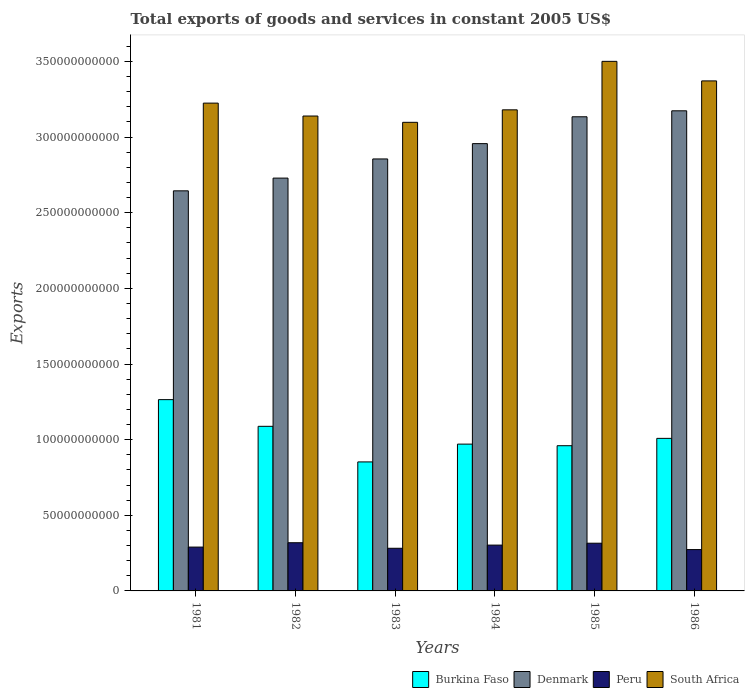How many groups of bars are there?
Keep it short and to the point. 6. How many bars are there on the 6th tick from the right?
Offer a very short reply. 4. What is the label of the 2nd group of bars from the left?
Make the answer very short. 1982. What is the total exports of goods and services in Peru in 1981?
Keep it short and to the point. 2.90e+1. Across all years, what is the maximum total exports of goods and services in Peru?
Provide a succinct answer. 3.19e+1. Across all years, what is the minimum total exports of goods and services in South Africa?
Your answer should be compact. 3.10e+11. In which year was the total exports of goods and services in Denmark maximum?
Ensure brevity in your answer.  1986. What is the total total exports of goods and services in Peru in the graph?
Your response must be concise. 1.78e+11. What is the difference between the total exports of goods and services in Peru in 1981 and that in 1984?
Keep it short and to the point. -1.32e+09. What is the difference between the total exports of goods and services in Denmark in 1981 and the total exports of goods and services in Burkina Faso in 1982?
Your response must be concise. 1.56e+11. What is the average total exports of goods and services in Denmark per year?
Give a very brief answer. 2.92e+11. In the year 1981, what is the difference between the total exports of goods and services in Denmark and total exports of goods and services in Peru?
Give a very brief answer. 2.36e+11. What is the ratio of the total exports of goods and services in Peru in 1982 to that in 1984?
Give a very brief answer. 1.05. Is the total exports of goods and services in Denmark in 1985 less than that in 1986?
Ensure brevity in your answer.  Yes. What is the difference between the highest and the second highest total exports of goods and services in Denmark?
Keep it short and to the point. 3.95e+09. What is the difference between the highest and the lowest total exports of goods and services in Denmark?
Your response must be concise. 5.29e+1. In how many years, is the total exports of goods and services in Burkina Faso greater than the average total exports of goods and services in Burkina Faso taken over all years?
Offer a terse response. 2. What does the 2nd bar from the left in 1986 represents?
Your response must be concise. Denmark. Is it the case that in every year, the sum of the total exports of goods and services in Burkina Faso and total exports of goods and services in Denmark is greater than the total exports of goods and services in Peru?
Offer a terse response. Yes. Are the values on the major ticks of Y-axis written in scientific E-notation?
Make the answer very short. No. Where does the legend appear in the graph?
Offer a very short reply. Bottom right. What is the title of the graph?
Keep it short and to the point. Total exports of goods and services in constant 2005 US$. What is the label or title of the Y-axis?
Your answer should be compact. Exports. What is the Exports in Burkina Faso in 1981?
Offer a terse response. 1.26e+11. What is the Exports in Denmark in 1981?
Your answer should be very brief. 2.64e+11. What is the Exports of Peru in 1981?
Your answer should be very brief. 2.90e+1. What is the Exports in South Africa in 1981?
Give a very brief answer. 3.22e+11. What is the Exports of Burkina Faso in 1982?
Your answer should be compact. 1.09e+11. What is the Exports in Denmark in 1982?
Your answer should be compact. 2.73e+11. What is the Exports of Peru in 1982?
Offer a terse response. 3.19e+1. What is the Exports in South Africa in 1982?
Your response must be concise. 3.14e+11. What is the Exports of Burkina Faso in 1983?
Offer a very short reply. 8.53e+1. What is the Exports of Denmark in 1983?
Give a very brief answer. 2.86e+11. What is the Exports of Peru in 1983?
Offer a very short reply. 2.82e+1. What is the Exports in South Africa in 1983?
Ensure brevity in your answer.  3.10e+11. What is the Exports in Burkina Faso in 1984?
Make the answer very short. 9.70e+1. What is the Exports of Denmark in 1984?
Provide a succinct answer. 2.96e+11. What is the Exports in Peru in 1984?
Provide a succinct answer. 3.03e+1. What is the Exports in South Africa in 1984?
Offer a very short reply. 3.18e+11. What is the Exports of Burkina Faso in 1985?
Your answer should be compact. 9.60e+1. What is the Exports of Denmark in 1985?
Keep it short and to the point. 3.13e+11. What is the Exports in Peru in 1985?
Give a very brief answer. 3.15e+1. What is the Exports in South Africa in 1985?
Make the answer very short. 3.50e+11. What is the Exports of Burkina Faso in 1986?
Your response must be concise. 1.01e+11. What is the Exports of Denmark in 1986?
Keep it short and to the point. 3.17e+11. What is the Exports of Peru in 1986?
Give a very brief answer. 2.73e+1. What is the Exports of South Africa in 1986?
Provide a succinct answer. 3.37e+11. Across all years, what is the maximum Exports in Burkina Faso?
Offer a terse response. 1.26e+11. Across all years, what is the maximum Exports of Denmark?
Give a very brief answer. 3.17e+11. Across all years, what is the maximum Exports of Peru?
Provide a succinct answer. 3.19e+1. Across all years, what is the maximum Exports of South Africa?
Ensure brevity in your answer.  3.50e+11. Across all years, what is the minimum Exports in Burkina Faso?
Make the answer very short. 8.53e+1. Across all years, what is the minimum Exports in Denmark?
Give a very brief answer. 2.64e+11. Across all years, what is the minimum Exports of Peru?
Your response must be concise. 2.73e+1. Across all years, what is the minimum Exports of South Africa?
Your answer should be compact. 3.10e+11. What is the total Exports of Burkina Faso in the graph?
Your response must be concise. 6.14e+11. What is the total Exports in Denmark in the graph?
Make the answer very short. 1.75e+12. What is the total Exports in Peru in the graph?
Provide a short and direct response. 1.78e+11. What is the total Exports in South Africa in the graph?
Offer a terse response. 1.95e+12. What is the difference between the Exports in Burkina Faso in 1981 and that in 1982?
Your answer should be very brief. 1.76e+1. What is the difference between the Exports in Denmark in 1981 and that in 1982?
Provide a succinct answer. -8.42e+09. What is the difference between the Exports of Peru in 1981 and that in 1982?
Your answer should be compact. -2.88e+09. What is the difference between the Exports of South Africa in 1981 and that in 1982?
Your response must be concise. 8.53e+09. What is the difference between the Exports in Burkina Faso in 1981 and that in 1983?
Ensure brevity in your answer.  4.12e+1. What is the difference between the Exports of Denmark in 1981 and that in 1983?
Provide a succinct answer. -2.11e+1. What is the difference between the Exports in Peru in 1981 and that in 1983?
Provide a succinct answer. 7.75e+08. What is the difference between the Exports of South Africa in 1981 and that in 1983?
Give a very brief answer. 1.27e+1. What is the difference between the Exports of Burkina Faso in 1981 and that in 1984?
Make the answer very short. 2.94e+1. What is the difference between the Exports in Denmark in 1981 and that in 1984?
Your answer should be compact. -3.12e+1. What is the difference between the Exports of Peru in 1981 and that in 1984?
Provide a succinct answer. -1.32e+09. What is the difference between the Exports of South Africa in 1981 and that in 1984?
Make the answer very short. 4.44e+09. What is the difference between the Exports in Burkina Faso in 1981 and that in 1985?
Provide a succinct answer. 3.05e+1. What is the difference between the Exports in Denmark in 1981 and that in 1985?
Offer a terse response. -4.90e+1. What is the difference between the Exports of Peru in 1981 and that in 1985?
Keep it short and to the point. -2.56e+09. What is the difference between the Exports in South Africa in 1981 and that in 1985?
Provide a succinct answer. -2.76e+1. What is the difference between the Exports in Burkina Faso in 1981 and that in 1986?
Ensure brevity in your answer.  2.56e+1. What is the difference between the Exports in Denmark in 1981 and that in 1986?
Your answer should be very brief. -5.29e+1. What is the difference between the Exports in Peru in 1981 and that in 1986?
Give a very brief answer. 1.64e+09. What is the difference between the Exports in South Africa in 1981 and that in 1986?
Ensure brevity in your answer.  -1.47e+1. What is the difference between the Exports of Burkina Faso in 1982 and that in 1983?
Your answer should be compact. 2.35e+1. What is the difference between the Exports of Denmark in 1982 and that in 1983?
Offer a terse response. -1.27e+1. What is the difference between the Exports of Peru in 1982 and that in 1983?
Offer a terse response. 3.66e+09. What is the difference between the Exports of South Africa in 1982 and that in 1983?
Keep it short and to the point. 4.17e+09. What is the difference between the Exports of Burkina Faso in 1982 and that in 1984?
Offer a terse response. 1.18e+1. What is the difference between the Exports in Denmark in 1982 and that in 1984?
Give a very brief answer. -2.28e+1. What is the difference between the Exports in Peru in 1982 and that in 1984?
Your answer should be very brief. 1.57e+09. What is the difference between the Exports in South Africa in 1982 and that in 1984?
Give a very brief answer. -4.09e+09. What is the difference between the Exports in Burkina Faso in 1982 and that in 1985?
Your answer should be compact. 1.28e+1. What is the difference between the Exports of Denmark in 1982 and that in 1985?
Provide a short and direct response. -4.05e+1. What is the difference between the Exports of Peru in 1982 and that in 1985?
Provide a succinct answer. 3.22e+08. What is the difference between the Exports of South Africa in 1982 and that in 1985?
Offer a terse response. -3.61e+1. What is the difference between the Exports in Burkina Faso in 1982 and that in 1986?
Make the answer very short. 7.96e+09. What is the difference between the Exports of Denmark in 1982 and that in 1986?
Keep it short and to the point. -4.45e+1. What is the difference between the Exports in Peru in 1982 and that in 1986?
Your answer should be very brief. 4.53e+09. What is the difference between the Exports of South Africa in 1982 and that in 1986?
Offer a very short reply. -2.32e+1. What is the difference between the Exports in Burkina Faso in 1983 and that in 1984?
Provide a succinct answer. -1.18e+1. What is the difference between the Exports of Denmark in 1983 and that in 1984?
Offer a terse response. -1.01e+1. What is the difference between the Exports of Peru in 1983 and that in 1984?
Make the answer very short. -2.09e+09. What is the difference between the Exports in South Africa in 1983 and that in 1984?
Offer a terse response. -8.26e+09. What is the difference between the Exports of Burkina Faso in 1983 and that in 1985?
Offer a very short reply. -1.07e+1. What is the difference between the Exports in Denmark in 1983 and that in 1985?
Your answer should be very brief. -2.79e+1. What is the difference between the Exports of Peru in 1983 and that in 1985?
Keep it short and to the point. -3.34e+09. What is the difference between the Exports of South Africa in 1983 and that in 1985?
Make the answer very short. -4.03e+1. What is the difference between the Exports in Burkina Faso in 1983 and that in 1986?
Keep it short and to the point. -1.56e+1. What is the difference between the Exports in Denmark in 1983 and that in 1986?
Offer a very short reply. -3.18e+1. What is the difference between the Exports of Peru in 1983 and that in 1986?
Your response must be concise. 8.69e+08. What is the difference between the Exports of South Africa in 1983 and that in 1986?
Your answer should be compact. -2.74e+1. What is the difference between the Exports of Burkina Faso in 1984 and that in 1985?
Ensure brevity in your answer.  1.05e+09. What is the difference between the Exports in Denmark in 1984 and that in 1985?
Give a very brief answer. -1.78e+1. What is the difference between the Exports in Peru in 1984 and that in 1985?
Keep it short and to the point. -1.25e+09. What is the difference between the Exports in South Africa in 1984 and that in 1985?
Keep it short and to the point. -3.20e+1. What is the difference between the Exports of Burkina Faso in 1984 and that in 1986?
Offer a very short reply. -3.80e+09. What is the difference between the Exports in Denmark in 1984 and that in 1986?
Keep it short and to the point. -2.17e+1. What is the difference between the Exports of Peru in 1984 and that in 1986?
Make the answer very short. 2.96e+09. What is the difference between the Exports in South Africa in 1984 and that in 1986?
Your response must be concise. -1.91e+1. What is the difference between the Exports in Burkina Faso in 1985 and that in 1986?
Ensure brevity in your answer.  -4.85e+09. What is the difference between the Exports of Denmark in 1985 and that in 1986?
Provide a succinct answer. -3.95e+09. What is the difference between the Exports in Peru in 1985 and that in 1986?
Give a very brief answer. 4.21e+09. What is the difference between the Exports in South Africa in 1985 and that in 1986?
Offer a very short reply. 1.29e+1. What is the difference between the Exports in Burkina Faso in 1981 and the Exports in Denmark in 1982?
Provide a short and direct response. -1.46e+11. What is the difference between the Exports in Burkina Faso in 1981 and the Exports in Peru in 1982?
Make the answer very short. 9.46e+1. What is the difference between the Exports in Burkina Faso in 1981 and the Exports in South Africa in 1982?
Your answer should be very brief. -1.87e+11. What is the difference between the Exports in Denmark in 1981 and the Exports in Peru in 1982?
Give a very brief answer. 2.33e+11. What is the difference between the Exports in Denmark in 1981 and the Exports in South Africa in 1982?
Make the answer very short. -4.95e+1. What is the difference between the Exports of Peru in 1981 and the Exports of South Africa in 1982?
Provide a succinct answer. -2.85e+11. What is the difference between the Exports in Burkina Faso in 1981 and the Exports in Denmark in 1983?
Make the answer very short. -1.59e+11. What is the difference between the Exports of Burkina Faso in 1981 and the Exports of Peru in 1983?
Give a very brief answer. 9.83e+1. What is the difference between the Exports of Burkina Faso in 1981 and the Exports of South Africa in 1983?
Your answer should be compact. -1.83e+11. What is the difference between the Exports in Denmark in 1981 and the Exports in Peru in 1983?
Offer a very short reply. 2.36e+11. What is the difference between the Exports of Denmark in 1981 and the Exports of South Africa in 1983?
Provide a succinct answer. -4.53e+1. What is the difference between the Exports of Peru in 1981 and the Exports of South Africa in 1983?
Give a very brief answer. -2.81e+11. What is the difference between the Exports of Burkina Faso in 1981 and the Exports of Denmark in 1984?
Give a very brief answer. -1.69e+11. What is the difference between the Exports in Burkina Faso in 1981 and the Exports in Peru in 1984?
Keep it short and to the point. 9.62e+1. What is the difference between the Exports in Burkina Faso in 1981 and the Exports in South Africa in 1984?
Provide a short and direct response. -1.92e+11. What is the difference between the Exports of Denmark in 1981 and the Exports of Peru in 1984?
Make the answer very short. 2.34e+11. What is the difference between the Exports of Denmark in 1981 and the Exports of South Africa in 1984?
Provide a succinct answer. -5.35e+1. What is the difference between the Exports in Peru in 1981 and the Exports in South Africa in 1984?
Your response must be concise. -2.89e+11. What is the difference between the Exports of Burkina Faso in 1981 and the Exports of Denmark in 1985?
Provide a succinct answer. -1.87e+11. What is the difference between the Exports in Burkina Faso in 1981 and the Exports in Peru in 1985?
Offer a terse response. 9.49e+1. What is the difference between the Exports of Burkina Faso in 1981 and the Exports of South Africa in 1985?
Your answer should be very brief. -2.24e+11. What is the difference between the Exports of Denmark in 1981 and the Exports of Peru in 1985?
Offer a terse response. 2.33e+11. What is the difference between the Exports of Denmark in 1981 and the Exports of South Africa in 1985?
Make the answer very short. -8.56e+1. What is the difference between the Exports in Peru in 1981 and the Exports in South Africa in 1985?
Your answer should be compact. -3.21e+11. What is the difference between the Exports of Burkina Faso in 1981 and the Exports of Denmark in 1986?
Your answer should be compact. -1.91e+11. What is the difference between the Exports in Burkina Faso in 1981 and the Exports in Peru in 1986?
Make the answer very short. 9.91e+1. What is the difference between the Exports in Burkina Faso in 1981 and the Exports in South Africa in 1986?
Keep it short and to the point. -2.11e+11. What is the difference between the Exports in Denmark in 1981 and the Exports in Peru in 1986?
Your answer should be very brief. 2.37e+11. What is the difference between the Exports in Denmark in 1981 and the Exports in South Africa in 1986?
Your answer should be very brief. -7.27e+1. What is the difference between the Exports of Peru in 1981 and the Exports of South Africa in 1986?
Your answer should be very brief. -3.08e+11. What is the difference between the Exports of Burkina Faso in 1982 and the Exports of Denmark in 1983?
Provide a succinct answer. -1.77e+11. What is the difference between the Exports of Burkina Faso in 1982 and the Exports of Peru in 1983?
Ensure brevity in your answer.  8.06e+1. What is the difference between the Exports of Burkina Faso in 1982 and the Exports of South Africa in 1983?
Give a very brief answer. -2.01e+11. What is the difference between the Exports in Denmark in 1982 and the Exports in Peru in 1983?
Keep it short and to the point. 2.45e+11. What is the difference between the Exports of Denmark in 1982 and the Exports of South Africa in 1983?
Give a very brief answer. -3.69e+1. What is the difference between the Exports of Peru in 1982 and the Exports of South Africa in 1983?
Offer a terse response. -2.78e+11. What is the difference between the Exports of Burkina Faso in 1982 and the Exports of Denmark in 1984?
Offer a very short reply. -1.87e+11. What is the difference between the Exports in Burkina Faso in 1982 and the Exports in Peru in 1984?
Offer a terse response. 7.85e+1. What is the difference between the Exports in Burkina Faso in 1982 and the Exports in South Africa in 1984?
Give a very brief answer. -2.09e+11. What is the difference between the Exports in Denmark in 1982 and the Exports in Peru in 1984?
Make the answer very short. 2.43e+11. What is the difference between the Exports of Denmark in 1982 and the Exports of South Africa in 1984?
Provide a short and direct response. -4.51e+1. What is the difference between the Exports in Peru in 1982 and the Exports in South Africa in 1984?
Provide a succinct answer. -2.86e+11. What is the difference between the Exports of Burkina Faso in 1982 and the Exports of Denmark in 1985?
Your response must be concise. -2.05e+11. What is the difference between the Exports in Burkina Faso in 1982 and the Exports in Peru in 1985?
Your answer should be very brief. 7.73e+1. What is the difference between the Exports in Burkina Faso in 1982 and the Exports in South Africa in 1985?
Offer a very short reply. -2.41e+11. What is the difference between the Exports of Denmark in 1982 and the Exports of Peru in 1985?
Give a very brief answer. 2.41e+11. What is the difference between the Exports in Denmark in 1982 and the Exports in South Africa in 1985?
Provide a succinct answer. -7.72e+1. What is the difference between the Exports of Peru in 1982 and the Exports of South Africa in 1985?
Offer a terse response. -3.18e+11. What is the difference between the Exports of Burkina Faso in 1982 and the Exports of Denmark in 1986?
Your response must be concise. -2.09e+11. What is the difference between the Exports in Burkina Faso in 1982 and the Exports in Peru in 1986?
Provide a succinct answer. 8.15e+1. What is the difference between the Exports of Burkina Faso in 1982 and the Exports of South Africa in 1986?
Your response must be concise. -2.28e+11. What is the difference between the Exports of Denmark in 1982 and the Exports of Peru in 1986?
Ensure brevity in your answer.  2.46e+11. What is the difference between the Exports of Denmark in 1982 and the Exports of South Africa in 1986?
Give a very brief answer. -6.43e+1. What is the difference between the Exports of Peru in 1982 and the Exports of South Africa in 1986?
Provide a succinct answer. -3.05e+11. What is the difference between the Exports in Burkina Faso in 1983 and the Exports in Denmark in 1984?
Your response must be concise. -2.10e+11. What is the difference between the Exports of Burkina Faso in 1983 and the Exports of Peru in 1984?
Offer a very short reply. 5.50e+1. What is the difference between the Exports in Burkina Faso in 1983 and the Exports in South Africa in 1984?
Provide a short and direct response. -2.33e+11. What is the difference between the Exports of Denmark in 1983 and the Exports of Peru in 1984?
Ensure brevity in your answer.  2.55e+11. What is the difference between the Exports in Denmark in 1983 and the Exports in South Africa in 1984?
Offer a very short reply. -3.25e+1. What is the difference between the Exports in Peru in 1983 and the Exports in South Africa in 1984?
Offer a very short reply. -2.90e+11. What is the difference between the Exports of Burkina Faso in 1983 and the Exports of Denmark in 1985?
Your response must be concise. -2.28e+11. What is the difference between the Exports of Burkina Faso in 1983 and the Exports of Peru in 1985?
Ensure brevity in your answer.  5.37e+1. What is the difference between the Exports in Burkina Faso in 1983 and the Exports in South Africa in 1985?
Provide a short and direct response. -2.65e+11. What is the difference between the Exports in Denmark in 1983 and the Exports in Peru in 1985?
Your response must be concise. 2.54e+11. What is the difference between the Exports in Denmark in 1983 and the Exports in South Africa in 1985?
Give a very brief answer. -6.45e+1. What is the difference between the Exports of Peru in 1983 and the Exports of South Africa in 1985?
Give a very brief answer. -3.22e+11. What is the difference between the Exports in Burkina Faso in 1983 and the Exports in Denmark in 1986?
Give a very brief answer. -2.32e+11. What is the difference between the Exports in Burkina Faso in 1983 and the Exports in Peru in 1986?
Provide a short and direct response. 5.80e+1. What is the difference between the Exports of Burkina Faso in 1983 and the Exports of South Africa in 1986?
Your response must be concise. -2.52e+11. What is the difference between the Exports of Denmark in 1983 and the Exports of Peru in 1986?
Provide a succinct answer. 2.58e+11. What is the difference between the Exports in Denmark in 1983 and the Exports in South Africa in 1986?
Give a very brief answer. -5.16e+1. What is the difference between the Exports of Peru in 1983 and the Exports of South Africa in 1986?
Ensure brevity in your answer.  -3.09e+11. What is the difference between the Exports in Burkina Faso in 1984 and the Exports in Denmark in 1985?
Provide a succinct answer. -2.16e+11. What is the difference between the Exports in Burkina Faso in 1984 and the Exports in Peru in 1985?
Provide a short and direct response. 6.55e+1. What is the difference between the Exports in Burkina Faso in 1984 and the Exports in South Africa in 1985?
Give a very brief answer. -2.53e+11. What is the difference between the Exports of Denmark in 1984 and the Exports of Peru in 1985?
Offer a terse response. 2.64e+11. What is the difference between the Exports in Denmark in 1984 and the Exports in South Africa in 1985?
Ensure brevity in your answer.  -5.44e+1. What is the difference between the Exports of Peru in 1984 and the Exports of South Africa in 1985?
Ensure brevity in your answer.  -3.20e+11. What is the difference between the Exports of Burkina Faso in 1984 and the Exports of Denmark in 1986?
Provide a short and direct response. -2.20e+11. What is the difference between the Exports in Burkina Faso in 1984 and the Exports in Peru in 1986?
Your response must be concise. 6.97e+1. What is the difference between the Exports of Burkina Faso in 1984 and the Exports of South Africa in 1986?
Your response must be concise. -2.40e+11. What is the difference between the Exports of Denmark in 1984 and the Exports of Peru in 1986?
Your answer should be compact. 2.68e+11. What is the difference between the Exports of Denmark in 1984 and the Exports of South Africa in 1986?
Offer a terse response. -4.15e+1. What is the difference between the Exports in Peru in 1984 and the Exports in South Africa in 1986?
Ensure brevity in your answer.  -3.07e+11. What is the difference between the Exports of Burkina Faso in 1985 and the Exports of Denmark in 1986?
Provide a succinct answer. -2.21e+11. What is the difference between the Exports in Burkina Faso in 1985 and the Exports in Peru in 1986?
Offer a very short reply. 6.87e+1. What is the difference between the Exports of Burkina Faso in 1985 and the Exports of South Africa in 1986?
Give a very brief answer. -2.41e+11. What is the difference between the Exports of Denmark in 1985 and the Exports of Peru in 1986?
Keep it short and to the point. 2.86e+11. What is the difference between the Exports in Denmark in 1985 and the Exports in South Africa in 1986?
Make the answer very short. -2.37e+1. What is the difference between the Exports of Peru in 1985 and the Exports of South Africa in 1986?
Provide a succinct answer. -3.06e+11. What is the average Exports of Burkina Faso per year?
Keep it short and to the point. 1.02e+11. What is the average Exports in Denmark per year?
Give a very brief answer. 2.92e+11. What is the average Exports in Peru per year?
Your answer should be compact. 2.97e+1. What is the average Exports in South Africa per year?
Keep it short and to the point. 3.25e+11. In the year 1981, what is the difference between the Exports in Burkina Faso and Exports in Denmark?
Keep it short and to the point. -1.38e+11. In the year 1981, what is the difference between the Exports of Burkina Faso and Exports of Peru?
Provide a succinct answer. 9.75e+1. In the year 1981, what is the difference between the Exports of Burkina Faso and Exports of South Africa?
Keep it short and to the point. -1.96e+11. In the year 1981, what is the difference between the Exports in Denmark and Exports in Peru?
Keep it short and to the point. 2.36e+11. In the year 1981, what is the difference between the Exports in Denmark and Exports in South Africa?
Offer a terse response. -5.80e+1. In the year 1981, what is the difference between the Exports of Peru and Exports of South Africa?
Ensure brevity in your answer.  -2.93e+11. In the year 1982, what is the difference between the Exports of Burkina Faso and Exports of Denmark?
Your answer should be compact. -1.64e+11. In the year 1982, what is the difference between the Exports of Burkina Faso and Exports of Peru?
Your answer should be very brief. 7.70e+1. In the year 1982, what is the difference between the Exports in Burkina Faso and Exports in South Africa?
Your answer should be very brief. -2.05e+11. In the year 1982, what is the difference between the Exports of Denmark and Exports of Peru?
Provide a succinct answer. 2.41e+11. In the year 1982, what is the difference between the Exports of Denmark and Exports of South Africa?
Offer a terse response. -4.10e+1. In the year 1982, what is the difference between the Exports of Peru and Exports of South Africa?
Provide a short and direct response. -2.82e+11. In the year 1983, what is the difference between the Exports of Burkina Faso and Exports of Denmark?
Offer a terse response. -2.00e+11. In the year 1983, what is the difference between the Exports of Burkina Faso and Exports of Peru?
Ensure brevity in your answer.  5.71e+1. In the year 1983, what is the difference between the Exports in Burkina Faso and Exports in South Africa?
Ensure brevity in your answer.  -2.24e+11. In the year 1983, what is the difference between the Exports in Denmark and Exports in Peru?
Provide a succinct answer. 2.57e+11. In the year 1983, what is the difference between the Exports in Denmark and Exports in South Africa?
Give a very brief answer. -2.42e+1. In the year 1983, what is the difference between the Exports in Peru and Exports in South Africa?
Make the answer very short. -2.82e+11. In the year 1984, what is the difference between the Exports of Burkina Faso and Exports of Denmark?
Offer a very short reply. -1.99e+11. In the year 1984, what is the difference between the Exports in Burkina Faso and Exports in Peru?
Your response must be concise. 6.68e+1. In the year 1984, what is the difference between the Exports in Burkina Faso and Exports in South Africa?
Keep it short and to the point. -2.21e+11. In the year 1984, what is the difference between the Exports in Denmark and Exports in Peru?
Provide a succinct answer. 2.65e+11. In the year 1984, what is the difference between the Exports of Denmark and Exports of South Africa?
Your response must be concise. -2.23e+1. In the year 1984, what is the difference between the Exports in Peru and Exports in South Africa?
Keep it short and to the point. -2.88e+11. In the year 1985, what is the difference between the Exports in Burkina Faso and Exports in Denmark?
Make the answer very short. -2.17e+11. In the year 1985, what is the difference between the Exports of Burkina Faso and Exports of Peru?
Keep it short and to the point. 6.45e+1. In the year 1985, what is the difference between the Exports in Burkina Faso and Exports in South Africa?
Give a very brief answer. -2.54e+11. In the year 1985, what is the difference between the Exports of Denmark and Exports of Peru?
Keep it short and to the point. 2.82e+11. In the year 1985, what is the difference between the Exports in Denmark and Exports in South Africa?
Provide a short and direct response. -3.66e+1. In the year 1985, what is the difference between the Exports in Peru and Exports in South Africa?
Provide a short and direct response. -3.19e+11. In the year 1986, what is the difference between the Exports in Burkina Faso and Exports in Denmark?
Provide a short and direct response. -2.17e+11. In the year 1986, what is the difference between the Exports in Burkina Faso and Exports in Peru?
Your answer should be compact. 7.35e+1. In the year 1986, what is the difference between the Exports of Burkina Faso and Exports of South Africa?
Offer a terse response. -2.36e+11. In the year 1986, what is the difference between the Exports in Denmark and Exports in Peru?
Offer a terse response. 2.90e+11. In the year 1986, what is the difference between the Exports in Denmark and Exports in South Africa?
Make the answer very short. -1.98e+1. In the year 1986, what is the difference between the Exports of Peru and Exports of South Africa?
Ensure brevity in your answer.  -3.10e+11. What is the ratio of the Exports of Burkina Faso in 1981 to that in 1982?
Ensure brevity in your answer.  1.16. What is the ratio of the Exports of Denmark in 1981 to that in 1982?
Give a very brief answer. 0.97. What is the ratio of the Exports in Peru in 1981 to that in 1982?
Make the answer very short. 0.91. What is the ratio of the Exports of South Africa in 1981 to that in 1982?
Offer a terse response. 1.03. What is the ratio of the Exports of Burkina Faso in 1981 to that in 1983?
Your answer should be very brief. 1.48. What is the ratio of the Exports in Denmark in 1981 to that in 1983?
Your response must be concise. 0.93. What is the ratio of the Exports of Peru in 1981 to that in 1983?
Your answer should be compact. 1.03. What is the ratio of the Exports in South Africa in 1981 to that in 1983?
Your response must be concise. 1.04. What is the ratio of the Exports in Burkina Faso in 1981 to that in 1984?
Offer a terse response. 1.3. What is the ratio of the Exports in Denmark in 1981 to that in 1984?
Provide a short and direct response. 0.89. What is the ratio of the Exports of Peru in 1981 to that in 1984?
Provide a succinct answer. 0.96. What is the ratio of the Exports in South Africa in 1981 to that in 1984?
Ensure brevity in your answer.  1.01. What is the ratio of the Exports of Burkina Faso in 1981 to that in 1985?
Your answer should be very brief. 1.32. What is the ratio of the Exports of Denmark in 1981 to that in 1985?
Keep it short and to the point. 0.84. What is the ratio of the Exports in Peru in 1981 to that in 1985?
Keep it short and to the point. 0.92. What is the ratio of the Exports of South Africa in 1981 to that in 1985?
Your answer should be very brief. 0.92. What is the ratio of the Exports of Burkina Faso in 1981 to that in 1986?
Your answer should be very brief. 1.25. What is the ratio of the Exports in Denmark in 1981 to that in 1986?
Make the answer very short. 0.83. What is the ratio of the Exports in Peru in 1981 to that in 1986?
Your answer should be very brief. 1.06. What is the ratio of the Exports in South Africa in 1981 to that in 1986?
Provide a short and direct response. 0.96. What is the ratio of the Exports of Burkina Faso in 1982 to that in 1983?
Offer a very short reply. 1.28. What is the ratio of the Exports of Denmark in 1982 to that in 1983?
Ensure brevity in your answer.  0.96. What is the ratio of the Exports in Peru in 1982 to that in 1983?
Provide a short and direct response. 1.13. What is the ratio of the Exports of South Africa in 1982 to that in 1983?
Provide a succinct answer. 1.01. What is the ratio of the Exports of Burkina Faso in 1982 to that in 1984?
Offer a very short reply. 1.12. What is the ratio of the Exports in Denmark in 1982 to that in 1984?
Your response must be concise. 0.92. What is the ratio of the Exports in Peru in 1982 to that in 1984?
Your answer should be very brief. 1.05. What is the ratio of the Exports of South Africa in 1982 to that in 1984?
Ensure brevity in your answer.  0.99. What is the ratio of the Exports of Burkina Faso in 1982 to that in 1985?
Offer a terse response. 1.13. What is the ratio of the Exports of Denmark in 1982 to that in 1985?
Provide a short and direct response. 0.87. What is the ratio of the Exports in Peru in 1982 to that in 1985?
Provide a succinct answer. 1.01. What is the ratio of the Exports of South Africa in 1982 to that in 1985?
Keep it short and to the point. 0.9. What is the ratio of the Exports of Burkina Faso in 1982 to that in 1986?
Your response must be concise. 1.08. What is the ratio of the Exports in Denmark in 1982 to that in 1986?
Make the answer very short. 0.86. What is the ratio of the Exports of Peru in 1982 to that in 1986?
Your answer should be compact. 1.17. What is the ratio of the Exports in South Africa in 1982 to that in 1986?
Your response must be concise. 0.93. What is the ratio of the Exports in Burkina Faso in 1983 to that in 1984?
Provide a short and direct response. 0.88. What is the ratio of the Exports of Denmark in 1983 to that in 1984?
Offer a terse response. 0.97. What is the ratio of the Exports in Peru in 1983 to that in 1984?
Your response must be concise. 0.93. What is the ratio of the Exports of Burkina Faso in 1983 to that in 1985?
Offer a terse response. 0.89. What is the ratio of the Exports in Denmark in 1983 to that in 1985?
Your answer should be compact. 0.91. What is the ratio of the Exports of Peru in 1983 to that in 1985?
Provide a short and direct response. 0.89. What is the ratio of the Exports in South Africa in 1983 to that in 1985?
Provide a short and direct response. 0.88. What is the ratio of the Exports in Burkina Faso in 1983 to that in 1986?
Provide a succinct answer. 0.85. What is the ratio of the Exports of Denmark in 1983 to that in 1986?
Make the answer very short. 0.9. What is the ratio of the Exports of Peru in 1983 to that in 1986?
Your answer should be compact. 1.03. What is the ratio of the Exports of South Africa in 1983 to that in 1986?
Your answer should be compact. 0.92. What is the ratio of the Exports of Burkina Faso in 1984 to that in 1985?
Provide a succinct answer. 1.01. What is the ratio of the Exports in Denmark in 1984 to that in 1985?
Your response must be concise. 0.94. What is the ratio of the Exports of Peru in 1984 to that in 1985?
Provide a succinct answer. 0.96. What is the ratio of the Exports in South Africa in 1984 to that in 1985?
Give a very brief answer. 0.91. What is the ratio of the Exports of Burkina Faso in 1984 to that in 1986?
Your answer should be very brief. 0.96. What is the ratio of the Exports of Denmark in 1984 to that in 1986?
Your answer should be very brief. 0.93. What is the ratio of the Exports in Peru in 1984 to that in 1986?
Your answer should be very brief. 1.11. What is the ratio of the Exports of South Africa in 1984 to that in 1986?
Provide a short and direct response. 0.94. What is the ratio of the Exports in Burkina Faso in 1985 to that in 1986?
Make the answer very short. 0.95. What is the ratio of the Exports in Denmark in 1985 to that in 1986?
Your response must be concise. 0.99. What is the ratio of the Exports of Peru in 1985 to that in 1986?
Give a very brief answer. 1.15. What is the ratio of the Exports of South Africa in 1985 to that in 1986?
Your answer should be compact. 1.04. What is the difference between the highest and the second highest Exports in Burkina Faso?
Make the answer very short. 1.76e+1. What is the difference between the highest and the second highest Exports in Denmark?
Your answer should be compact. 3.95e+09. What is the difference between the highest and the second highest Exports in Peru?
Keep it short and to the point. 3.22e+08. What is the difference between the highest and the second highest Exports of South Africa?
Your answer should be very brief. 1.29e+1. What is the difference between the highest and the lowest Exports of Burkina Faso?
Make the answer very short. 4.12e+1. What is the difference between the highest and the lowest Exports in Denmark?
Make the answer very short. 5.29e+1. What is the difference between the highest and the lowest Exports of Peru?
Make the answer very short. 4.53e+09. What is the difference between the highest and the lowest Exports in South Africa?
Your answer should be compact. 4.03e+1. 